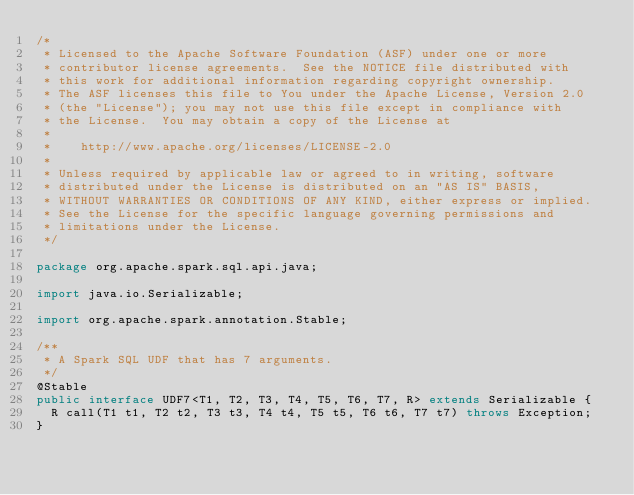<code> <loc_0><loc_0><loc_500><loc_500><_Java_>/*
 * Licensed to the Apache Software Foundation (ASF) under one or more
 * contributor license agreements.  See the NOTICE file distributed with
 * this work for additional information regarding copyright ownership.
 * The ASF licenses this file to You under the Apache License, Version 2.0
 * (the "License"); you may not use this file except in compliance with
 * the License.  You may obtain a copy of the License at
 *
 *    http://www.apache.org/licenses/LICENSE-2.0
 *
 * Unless required by applicable law or agreed to in writing, software
 * distributed under the License is distributed on an "AS IS" BASIS,
 * WITHOUT WARRANTIES OR CONDITIONS OF ANY KIND, either express or implied.
 * See the License for the specific language governing permissions and
 * limitations under the License.
 */

package org.apache.spark.sql.api.java;

import java.io.Serializable;

import org.apache.spark.annotation.Stable;

/**
 * A Spark SQL UDF that has 7 arguments.
 */
@Stable
public interface UDF7<T1, T2, T3, T4, T5, T6, T7, R> extends Serializable {
  R call(T1 t1, T2 t2, T3 t3, T4 t4, T5 t5, T6 t6, T7 t7) throws Exception;
}
</code> 